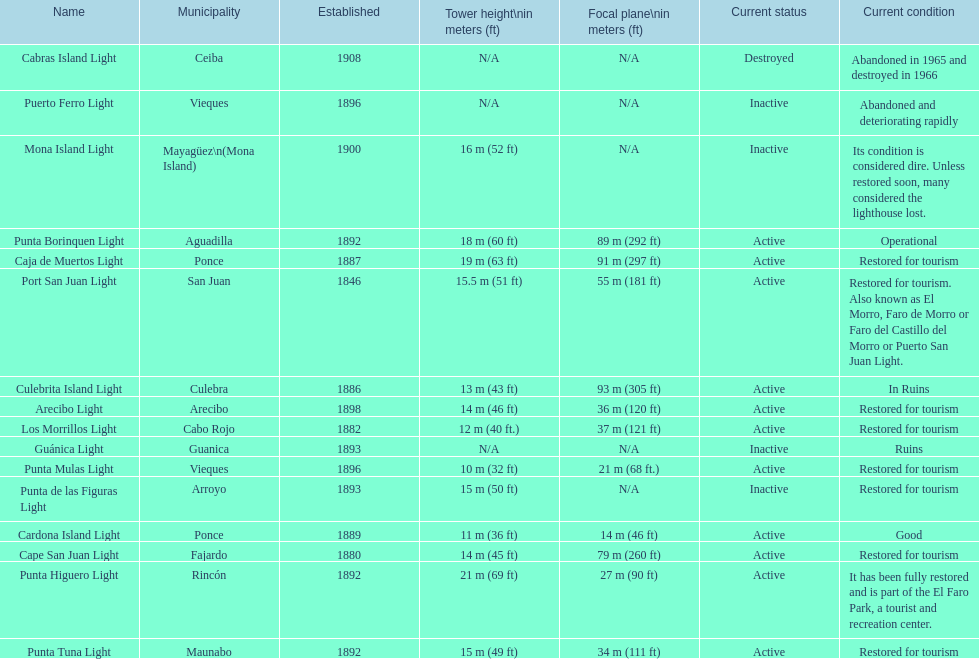Would you mind parsing the complete table? {'header': ['Name', 'Municipality', 'Established', 'Tower height\\nin meters (ft)', 'Focal plane\\nin meters (ft)', 'Current status', 'Current condition'], 'rows': [['Cabras Island Light', 'Ceiba', '1908', 'N/A', 'N/A', 'Destroyed', 'Abandoned in 1965 and destroyed in 1966'], ['Puerto Ferro Light', 'Vieques', '1896', 'N/A', 'N/A', 'Inactive', 'Abandoned and deteriorating rapidly'], ['Mona Island Light', 'Mayagüez\\n(Mona Island)', '1900', '16\xa0m (52\xa0ft)', 'N/A', 'Inactive', 'Its condition is considered dire. Unless restored soon, many considered the lighthouse lost.'], ['Punta Borinquen Light', 'Aguadilla', '1892', '18\xa0m (60\xa0ft)', '89\xa0m (292\xa0ft)', 'Active', 'Operational'], ['Caja de Muertos Light', 'Ponce', '1887', '19\xa0m (63\xa0ft)', '91\xa0m (297\xa0ft)', 'Active', 'Restored for tourism'], ['Port San Juan Light', 'San Juan', '1846', '15.5\xa0m (51\xa0ft)', '55\xa0m (181\xa0ft)', 'Active', 'Restored for tourism. Also known as El Morro, Faro de Morro or Faro del Castillo del Morro or Puerto San Juan Light.'], ['Culebrita Island Light', 'Culebra', '1886', '13\xa0m (43\xa0ft)', '93\xa0m (305\xa0ft)', 'Active', 'In Ruins'], ['Arecibo Light', 'Arecibo', '1898', '14\xa0m (46\xa0ft)', '36\xa0m (120\xa0ft)', 'Active', 'Restored for tourism'], ['Los Morrillos Light', 'Cabo Rojo', '1882', '12\xa0m (40\xa0ft.)', '37\xa0m (121\xa0ft)', 'Active', 'Restored for tourism'], ['Guánica Light', 'Guanica', '1893', 'N/A', 'N/A', 'Inactive', 'Ruins'], ['Punta Mulas Light', 'Vieques', '1896', '10\xa0m (32\xa0ft)', '21\xa0m (68\xa0ft.)', 'Active', 'Restored for tourism'], ['Punta de las Figuras Light', 'Arroyo', '1893', '15\xa0m (50\xa0ft)', 'N/A', 'Inactive', 'Restored for tourism'], ['Cardona Island Light', 'Ponce', '1889', '11\xa0m (36\xa0ft)', '14\xa0m (46\xa0ft)', 'Active', 'Good'], ['Cape San Juan Light', 'Fajardo', '1880', '14\xa0m (45\xa0ft)', '79\xa0m (260\xa0ft)', 'Active', 'Restored for tourism'], ['Punta Higuero Light', 'Rincón', '1892', '21\xa0m (69\xa0ft)', '27\xa0m (90\xa0ft)', 'Active', 'It has been fully restored and is part of the El Faro Park, a tourist and recreation center.'], ['Punta Tuna Light', 'Maunabo', '1892', '15\xa0m (49\xa0ft)', '34\xa0m (111\xa0ft)', 'Active', 'Restored for tourism']]} How many establishments are restored for tourism? 9. 